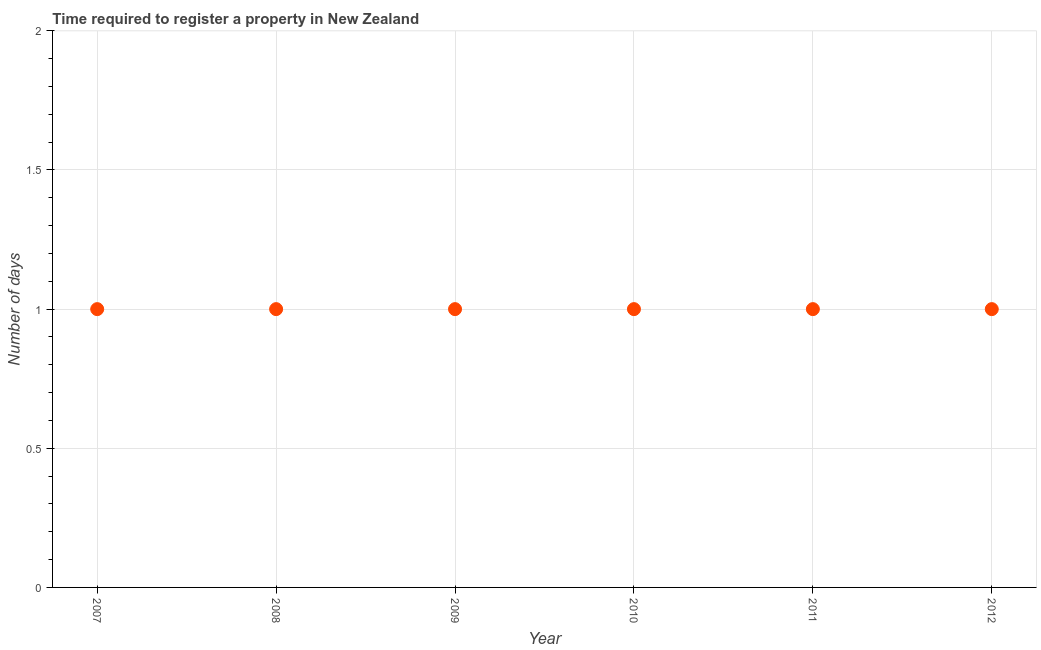What is the number of days required to register property in 2012?
Give a very brief answer. 1. Across all years, what is the maximum number of days required to register property?
Give a very brief answer. 1. Across all years, what is the minimum number of days required to register property?
Your response must be concise. 1. In which year was the number of days required to register property maximum?
Provide a short and direct response. 2007. In which year was the number of days required to register property minimum?
Your response must be concise. 2007. What is the difference between the number of days required to register property in 2007 and 2011?
Your answer should be compact. 0. What is the average number of days required to register property per year?
Ensure brevity in your answer.  1. What is the median number of days required to register property?
Make the answer very short. 1. In how many years, is the number of days required to register property greater than 1.2 days?
Provide a short and direct response. 0. What is the ratio of the number of days required to register property in 2008 to that in 2011?
Ensure brevity in your answer.  1. Is the sum of the number of days required to register property in 2009 and 2010 greater than the maximum number of days required to register property across all years?
Your answer should be very brief. Yes. What is the difference between the highest and the lowest number of days required to register property?
Offer a terse response. 0. In how many years, is the number of days required to register property greater than the average number of days required to register property taken over all years?
Offer a very short reply. 0. Are the values on the major ticks of Y-axis written in scientific E-notation?
Your answer should be compact. No. Does the graph contain any zero values?
Provide a succinct answer. No. What is the title of the graph?
Offer a terse response. Time required to register a property in New Zealand. What is the label or title of the Y-axis?
Offer a very short reply. Number of days. What is the Number of days in 2007?
Your response must be concise. 1. What is the Number of days in 2012?
Your answer should be compact. 1. What is the difference between the Number of days in 2007 and 2008?
Offer a very short reply. 0. What is the difference between the Number of days in 2007 and 2009?
Provide a short and direct response. 0. What is the difference between the Number of days in 2007 and 2010?
Provide a succinct answer. 0. What is the difference between the Number of days in 2007 and 2011?
Provide a short and direct response. 0. What is the difference between the Number of days in 2007 and 2012?
Keep it short and to the point. 0. What is the difference between the Number of days in 2008 and 2011?
Give a very brief answer. 0. What is the difference between the Number of days in 2009 and 2010?
Your answer should be very brief. 0. What is the difference between the Number of days in 2009 and 2012?
Keep it short and to the point. 0. What is the difference between the Number of days in 2010 and 2011?
Keep it short and to the point. 0. What is the difference between the Number of days in 2011 and 2012?
Offer a terse response. 0. What is the ratio of the Number of days in 2007 to that in 2008?
Provide a short and direct response. 1. What is the ratio of the Number of days in 2007 to that in 2009?
Ensure brevity in your answer.  1. What is the ratio of the Number of days in 2007 to that in 2010?
Your response must be concise. 1. What is the ratio of the Number of days in 2007 to that in 2011?
Provide a succinct answer. 1. What is the ratio of the Number of days in 2007 to that in 2012?
Ensure brevity in your answer.  1. What is the ratio of the Number of days in 2008 to that in 2009?
Make the answer very short. 1. What is the ratio of the Number of days in 2008 to that in 2010?
Your answer should be very brief. 1. What is the ratio of the Number of days in 2009 to that in 2010?
Your answer should be very brief. 1. What is the ratio of the Number of days in 2010 to that in 2012?
Your answer should be very brief. 1. 